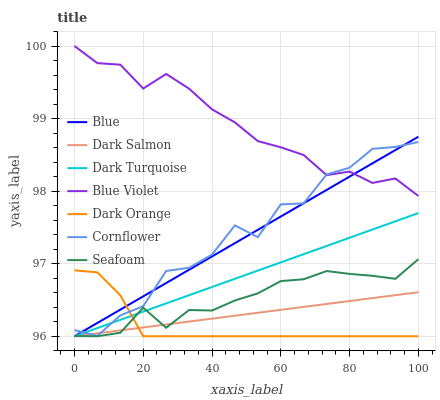Does Dark Orange have the minimum area under the curve?
Answer yes or no. Yes. Does Blue Violet have the maximum area under the curve?
Answer yes or no. Yes. Does Cornflower have the minimum area under the curve?
Answer yes or no. No. Does Cornflower have the maximum area under the curve?
Answer yes or no. No. Is Dark Turquoise the smoothest?
Answer yes or no. Yes. Is Cornflower the roughest?
Answer yes or no. Yes. Is Dark Orange the smoothest?
Answer yes or no. No. Is Dark Orange the roughest?
Answer yes or no. No. Does Blue have the lowest value?
Answer yes or no. Yes. Does Cornflower have the lowest value?
Answer yes or no. No. Does Blue Violet have the highest value?
Answer yes or no. Yes. Does Cornflower have the highest value?
Answer yes or no. No. Is Seafoam less than Cornflower?
Answer yes or no. Yes. Is Blue Violet greater than Dark Salmon?
Answer yes or no. Yes. Does Dark Turquoise intersect Dark Salmon?
Answer yes or no. Yes. Is Dark Turquoise less than Dark Salmon?
Answer yes or no. No. Is Dark Turquoise greater than Dark Salmon?
Answer yes or no. No. Does Seafoam intersect Cornflower?
Answer yes or no. No. 